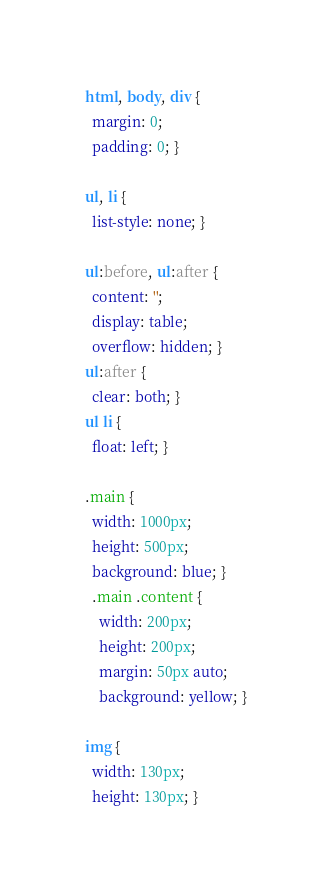<code> <loc_0><loc_0><loc_500><loc_500><_CSS_>html, body, div {
  margin: 0;
  padding: 0; }

ul, li {
  list-style: none; }

ul:before, ul:after {
  content: '';
  display: table;
  overflow: hidden; }
ul:after {
  clear: both; }
ul li {
  float: left; }

.main {
  width: 1000px;
  height: 500px;
  background: blue; }
  .main .content {
    width: 200px;
    height: 200px;
    margin: 50px auto;
    background: yellow; }

img {
  width: 130px;
  height: 130px; }
</code> 